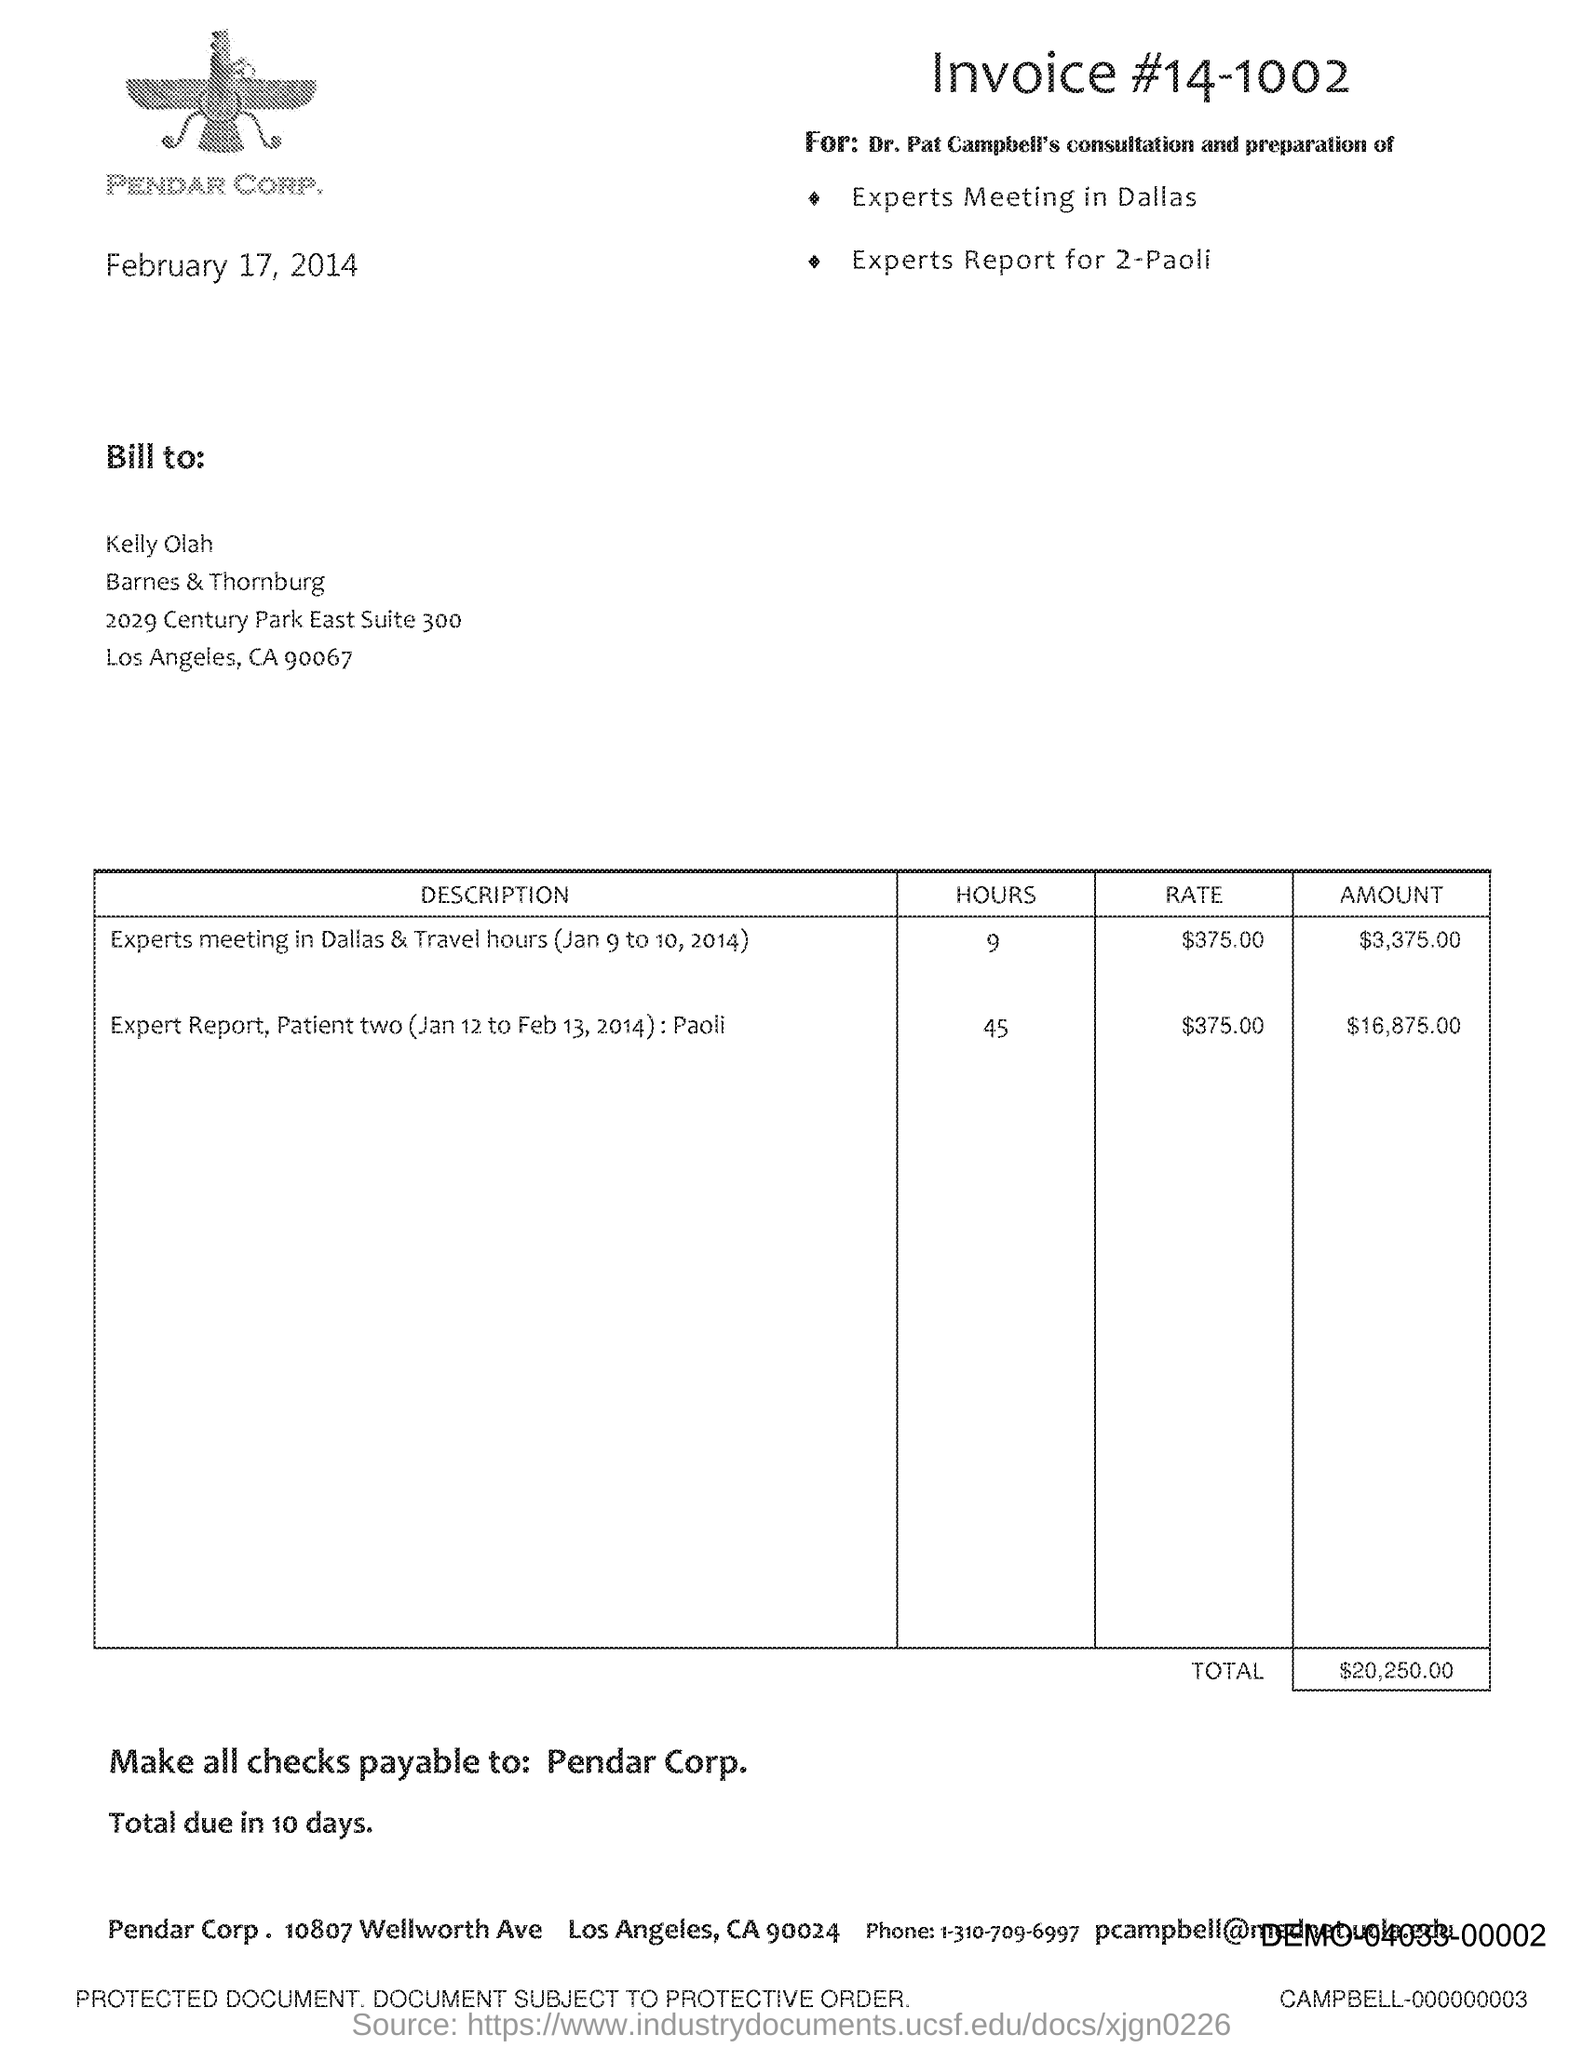Specify some key components in this picture. The payee of the checks should be made out to 'Pendar Corp.' The total amount for the expert report is $16,875.00. The bill should be addressed to Kelly Olah. The total is due in ten days. The cost for expert meetings in Dallas, including travel hours, is $375.00. 